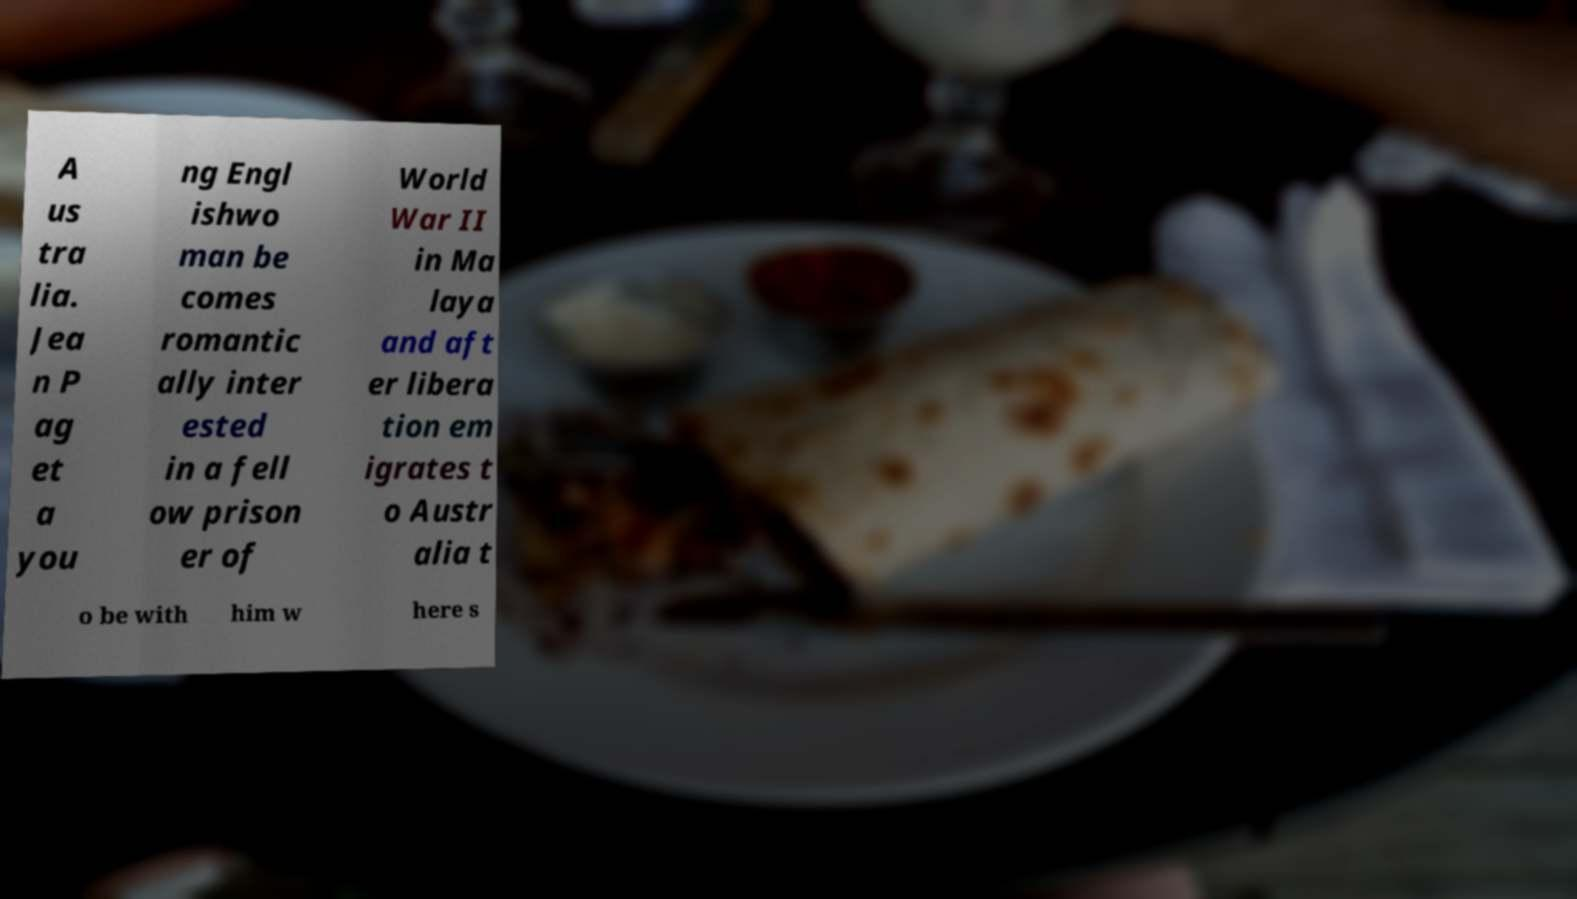For documentation purposes, I need the text within this image transcribed. Could you provide that? A us tra lia. Jea n P ag et a you ng Engl ishwo man be comes romantic ally inter ested in a fell ow prison er of World War II in Ma laya and aft er libera tion em igrates t o Austr alia t o be with him w here s 